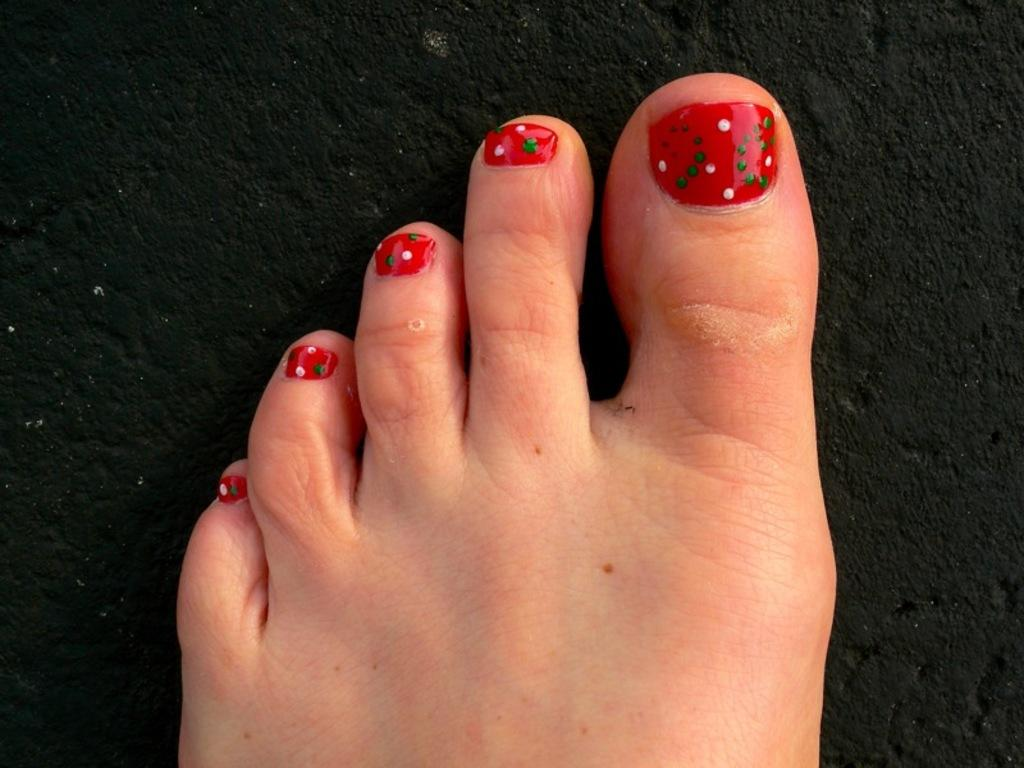What part of a person's body can be seen in the image? There is a person's foot visible in the image. What type of fruit is the person holding in the image? There is no fruit visible in the image; only a person's foot can be seen. 